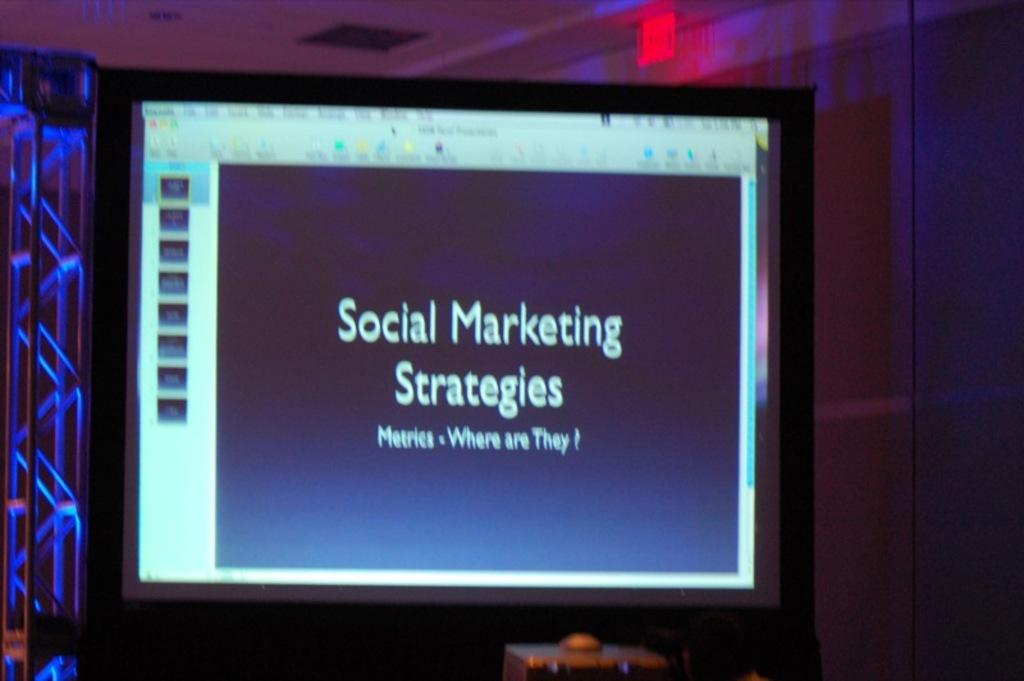What is the title of the presentation?
Ensure brevity in your answer.  Social marketing strategies. 